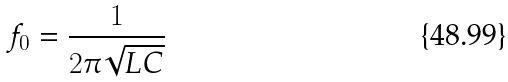<formula> <loc_0><loc_0><loc_500><loc_500>f _ { 0 } = \frac { 1 } { 2 \pi \sqrt { L C } }</formula> 